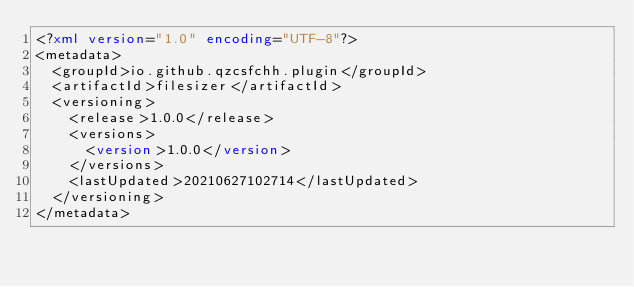Convert code to text. <code><loc_0><loc_0><loc_500><loc_500><_XML_><?xml version="1.0" encoding="UTF-8"?>
<metadata>
  <groupId>io.github.qzcsfchh.plugin</groupId>
  <artifactId>filesizer</artifactId>
  <versioning>
    <release>1.0.0</release>
    <versions>
      <version>1.0.0</version>
    </versions>
    <lastUpdated>20210627102714</lastUpdated>
  </versioning>
</metadata>
</code> 